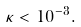<formula> <loc_0><loc_0><loc_500><loc_500>\kappa < 1 0 ^ { - 3 } .</formula> 